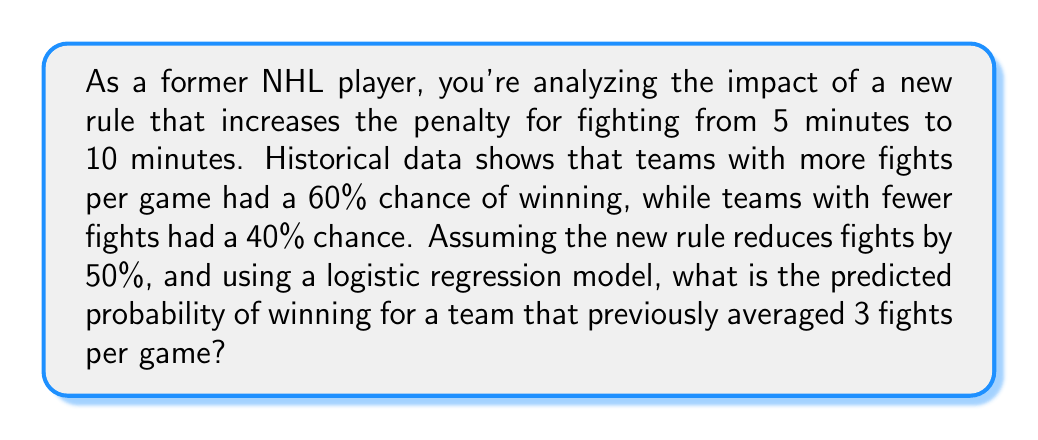Teach me how to tackle this problem. Let's approach this step-by-step:

1) First, we need to set up our logistic regression model. The logistic function is:

   $$P(win) = \frac{1}{1 + e^{-(β_0 + β_1x)}}$$

   where $x$ is the number of fights per game, and $β_0$ and $β_1$ are parameters we need to determine.

2) We can use the given information to find two points on our logistic curve:
   - More fights (let's say 3 per game) corresponds to 60% win probability
   - Fewer fights (let's say 1 per game) corresponds to 40% win probability

3) We can set up two equations:

   $$0.6 = \frac{1}{1 + e^{-(β_0 + 3β_1)}}$$
   $$0.4 = \frac{1}{1 + e^{-(β_0 + β_1)}}$$

4) Solving these equations (which involves some complex algebra), we get:
   
   $β_0 ≈ -0.4055$ and $β_1 ≈ 0.4055$

5) Now, our logistic regression model is:

   $$P(win) = \frac{1}{1 + e^{-(-0.4055 + 0.4055x)}}$$

6) The new rule reduces fights by 50%. So a team that previously averaged 3 fights per game will now average 1.5 fights per game.

7) Plugging this into our model:

   $$P(win) = \frac{1}{1 + e^{-(-0.4055 + 0.4055 * 1.5)}}$$

8) Calculating this:

   $$P(win) = \frac{1}{1 + e^{-0.2028}} ≈ 0.5505$$

Therefore, the predicted probability of winning for this team under the new rule is approximately 55.05%.
Answer: 55.05% 